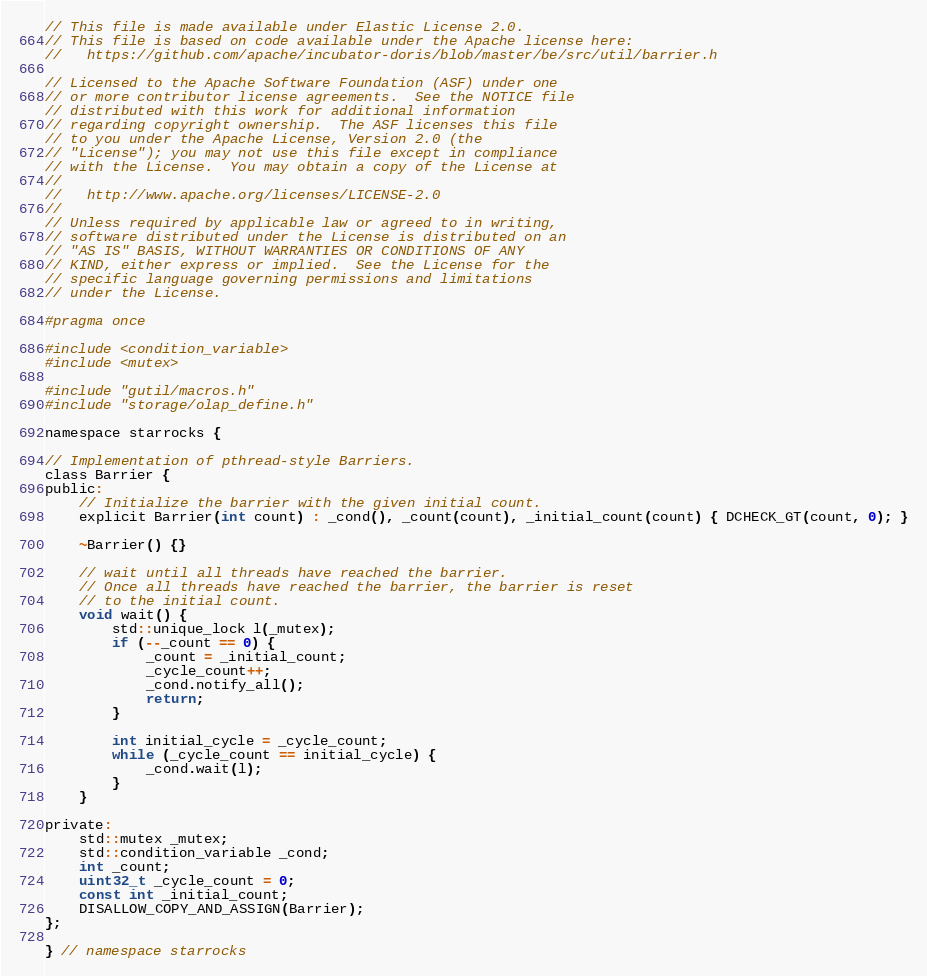Convert code to text. <code><loc_0><loc_0><loc_500><loc_500><_C_>// This file is made available under Elastic License 2.0.
// This file is based on code available under the Apache license here:
//   https://github.com/apache/incubator-doris/blob/master/be/src/util/barrier.h

// Licensed to the Apache Software Foundation (ASF) under one
// or more contributor license agreements.  See the NOTICE file
// distributed with this work for additional information
// regarding copyright ownership.  The ASF licenses this file
// to you under the Apache License, Version 2.0 (the
// "License"); you may not use this file except in compliance
// with the License.  You may obtain a copy of the License at
//
//   http://www.apache.org/licenses/LICENSE-2.0
//
// Unless required by applicable law or agreed to in writing,
// software distributed under the License is distributed on an
// "AS IS" BASIS, WITHOUT WARRANTIES OR CONDITIONS OF ANY
// KIND, either express or implied.  See the License for the
// specific language governing permissions and limitations
// under the License.

#pragma once

#include <condition_variable>
#include <mutex>

#include "gutil/macros.h"
#include "storage/olap_define.h"

namespace starrocks {

// Implementation of pthread-style Barriers.
class Barrier {
public:
    // Initialize the barrier with the given initial count.
    explicit Barrier(int count) : _cond(), _count(count), _initial_count(count) { DCHECK_GT(count, 0); }

    ~Barrier() {}

    // wait until all threads have reached the barrier.
    // Once all threads have reached the barrier, the barrier is reset
    // to the initial count.
    void wait() {
        std::unique_lock l(_mutex);
        if (--_count == 0) {
            _count = _initial_count;
            _cycle_count++;
            _cond.notify_all();
            return;
        }

        int initial_cycle = _cycle_count;
        while (_cycle_count == initial_cycle) {
            _cond.wait(l);
        }
    }

private:
    std::mutex _mutex;
    std::condition_variable _cond;
    int _count;
    uint32_t _cycle_count = 0;
    const int _initial_count;
    DISALLOW_COPY_AND_ASSIGN(Barrier);
};

} // namespace starrocks
</code> 